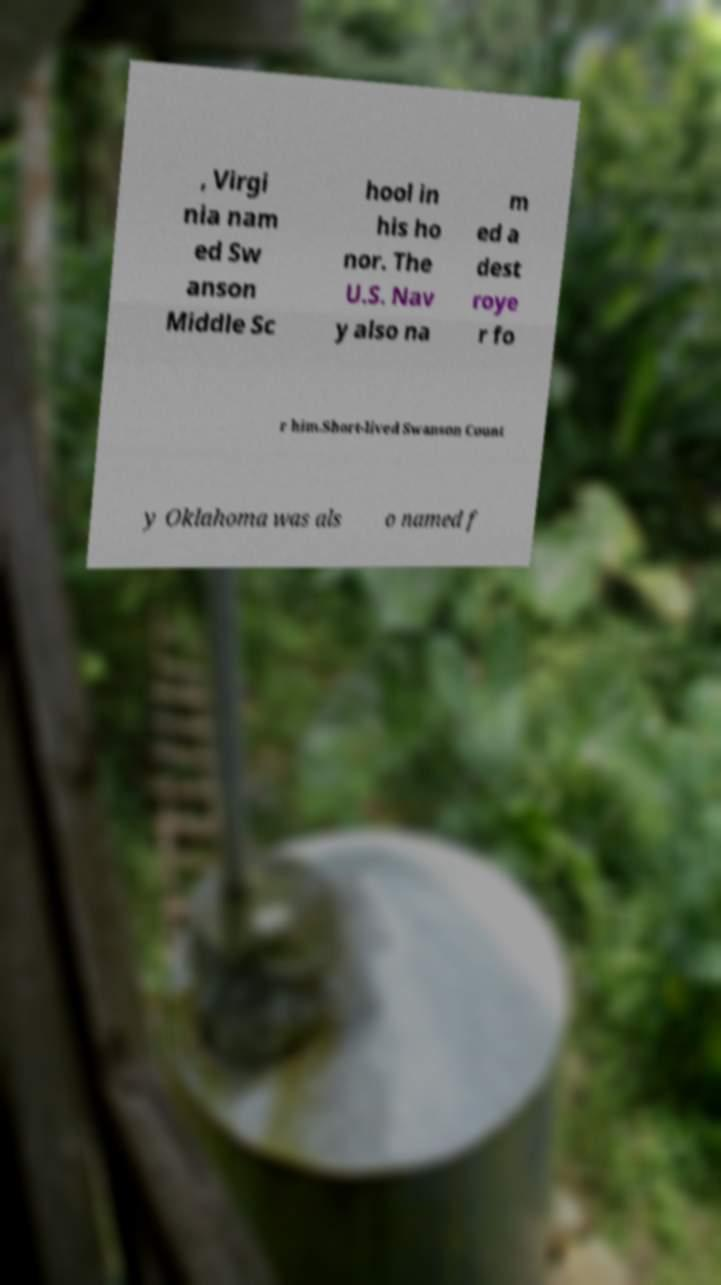Could you assist in decoding the text presented in this image and type it out clearly? , Virgi nia nam ed Sw anson Middle Sc hool in his ho nor. The U.S. Nav y also na m ed a dest roye r fo r him.Short-lived Swanson Count y Oklahoma was als o named f 